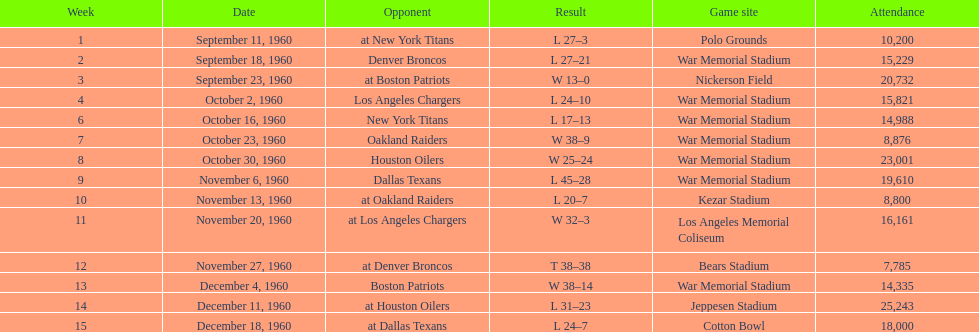How many times was war memorial stadium the game site? 6. 